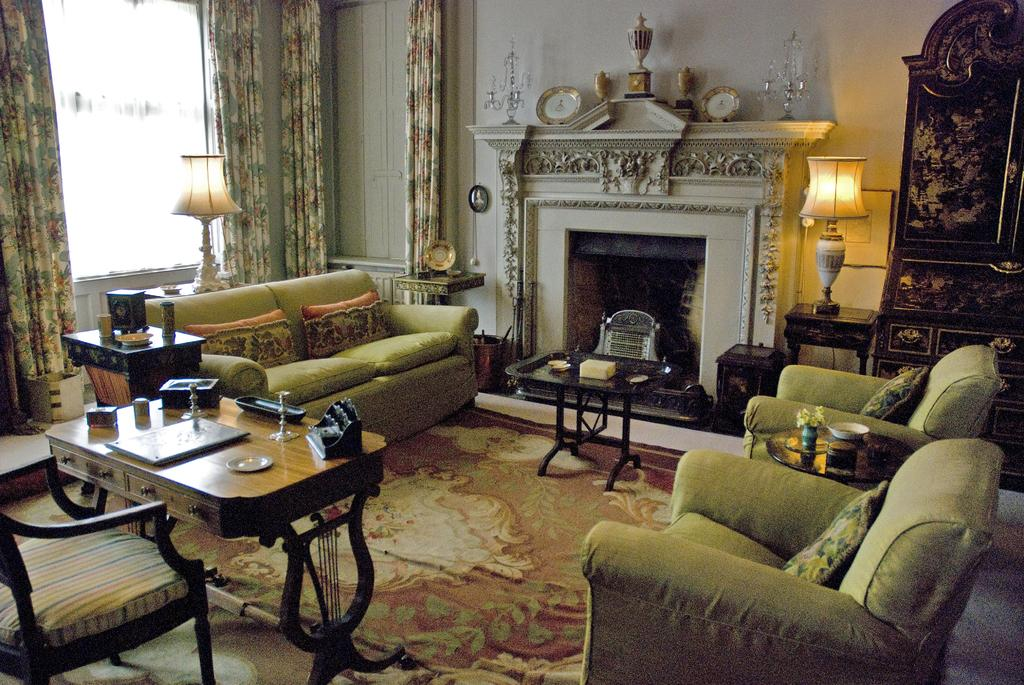What type of seating is available in the room? There is a sofa and chairs in the room. What is on the floor in the room? There are tables on the floor. What is on the tables in the room? There are lamps and objects on the tables. What is on the wall in the room? There is a clock on the wall. What is the purpose of the furniture in the room? The furniture in the room provides seating and surfaces for objects. What type of behavior can be observed from the stove in the room? There is no stove present in the room, so no behavior can be observed. What news is being reported by the objects on the table? There is no news being reported by the objects on the table; they are simply objects. 